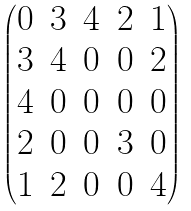<formula> <loc_0><loc_0><loc_500><loc_500>\begin{pmatrix} 0 & 3 & 4 & 2 & 1 \\ 3 & 4 & 0 & 0 & 2 \\ 4 & 0 & 0 & 0 & 0 \\ 2 & 0 & 0 & 3 & 0 \\ 1 & 2 & 0 & 0 & 4 \end{pmatrix}</formula> 